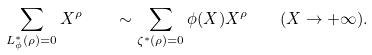<formula> <loc_0><loc_0><loc_500><loc_500>\sum _ { L _ { \phi } ^ { \ast } ( \rho ) = 0 } X ^ { \rho } \quad \sim \sum _ { \zeta ^ { \ast } ( \rho ) = 0 } \phi ( X ) X ^ { \rho } \quad ( X \to + \infty ) .</formula> 